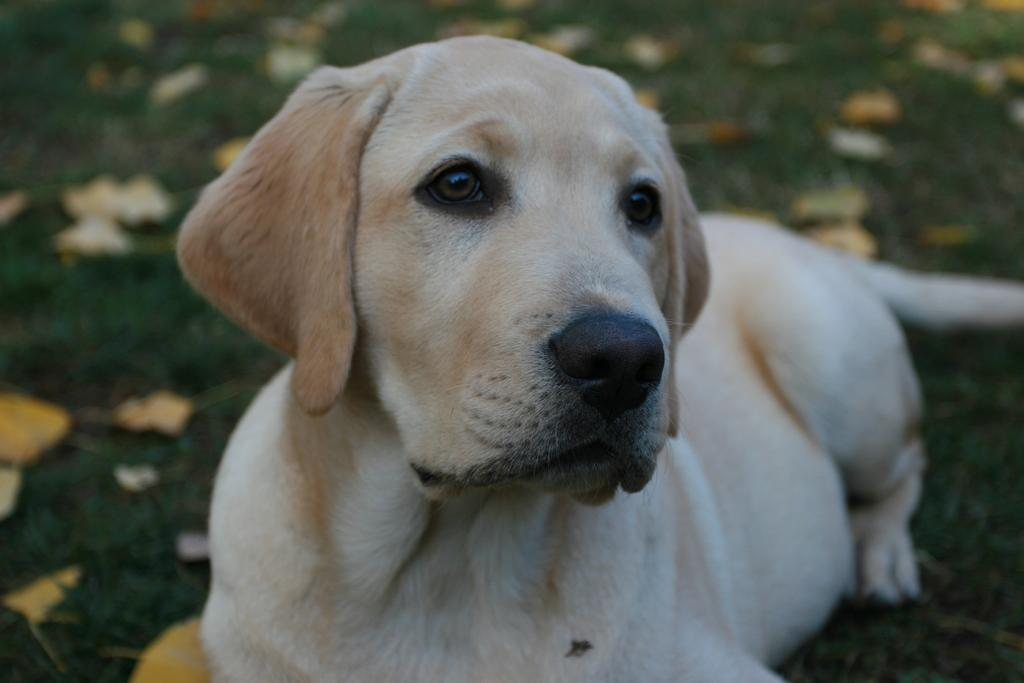What type of animal is in the image? There is a dog in the image. What is the dog doing in the image? The dog is sitting on the ground. What can be seen in the image besides the dog? There are leaves visible in the image. How would you describe the background of the image? The background of the image is blurred. How many men are needed to carry the dog in the image? There are no men present in the image, and the dog is sitting on the ground, so it does not need to be carried. How many houses can be seen in the image? There are no houses visible in the image; it primarily features a dog sitting on the ground with leaves and a blurred background. 